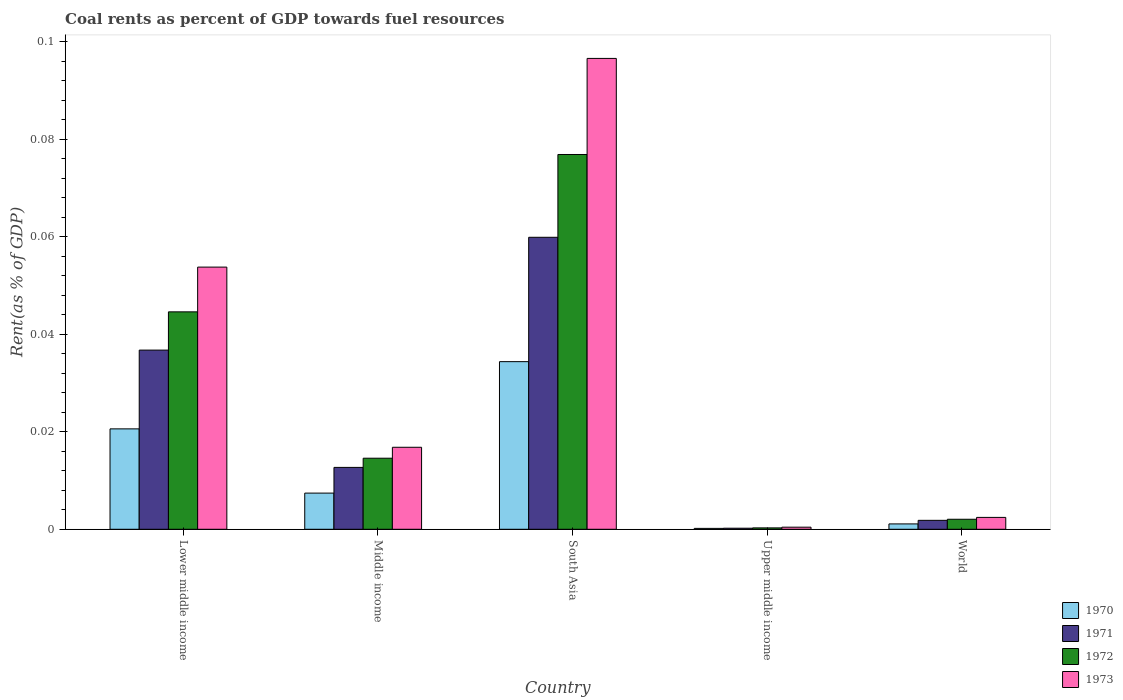How many different coloured bars are there?
Keep it short and to the point. 4. How many groups of bars are there?
Offer a terse response. 5. Are the number of bars on each tick of the X-axis equal?
Keep it short and to the point. Yes. How many bars are there on the 1st tick from the left?
Your answer should be very brief. 4. What is the label of the 5th group of bars from the left?
Give a very brief answer. World. What is the coal rent in 1972 in South Asia?
Your answer should be compact. 0.08. Across all countries, what is the maximum coal rent in 1973?
Your answer should be compact. 0.1. Across all countries, what is the minimum coal rent in 1970?
Offer a terse response. 0. In which country was the coal rent in 1972 maximum?
Make the answer very short. South Asia. In which country was the coal rent in 1973 minimum?
Make the answer very short. Upper middle income. What is the total coal rent in 1972 in the graph?
Provide a succinct answer. 0.14. What is the difference between the coal rent in 1972 in Lower middle income and that in South Asia?
Make the answer very short. -0.03. What is the difference between the coal rent in 1970 in Middle income and the coal rent in 1972 in South Asia?
Offer a terse response. -0.07. What is the average coal rent in 1973 per country?
Offer a terse response. 0.03. What is the difference between the coal rent of/in 1971 and coal rent of/in 1970 in Lower middle income?
Keep it short and to the point. 0.02. In how many countries, is the coal rent in 1970 greater than 0.056 %?
Offer a very short reply. 0. What is the ratio of the coal rent in 1971 in Middle income to that in World?
Your answer should be very brief. 6.93. Is the coal rent in 1973 in Lower middle income less than that in Middle income?
Offer a very short reply. No. What is the difference between the highest and the second highest coal rent in 1972?
Ensure brevity in your answer.  0.03. What is the difference between the highest and the lowest coal rent in 1971?
Provide a short and direct response. 0.06. Is it the case that in every country, the sum of the coal rent in 1970 and coal rent in 1972 is greater than the sum of coal rent in 1973 and coal rent in 1971?
Offer a terse response. No. What does the 1st bar from the left in Upper middle income represents?
Give a very brief answer. 1970. What does the 2nd bar from the right in South Asia represents?
Provide a succinct answer. 1972. What is the difference between two consecutive major ticks on the Y-axis?
Provide a short and direct response. 0.02. Are the values on the major ticks of Y-axis written in scientific E-notation?
Offer a very short reply. No. Where does the legend appear in the graph?
Give a very brief answer. Bottom right. How are the legend labels stacked?
Keep it short and to the point. Vertical. What is the title of the graph?
Keep it short and to the point. Coal rents as percent of GDP towards fuel resources. Does "1981" appear as one of the legend labels in the graph?
Offer a terse response. No. What is the label or title of the X-axis?
Offer a very short reply. Country. What is the label or title of the Y-axis?
Your response must be concise. Rent(as % of GDP). What is the Rent(as % of GDP) in 1970 in Lower middle income?
Your answer should be very brief. 0.02. What is the Rent(as % of GDP) of 1971 in Lower middle income?
Provide a short and direct response. 0.04. What is the Rent(as % of GDP) in 1972 in Lower middle income?
Give a very brief answer. 0.04. What is the Rent(as % of GDP) of 1973 in Lower middle income?
Your answer should be compact. 0.05. What is the Rent(as % of GDP) in 1970 in Middle income?
Your answer should be very brief. 0.01. What is the Rent(as % of GDP) of 1971 in Middle income?
Make the answer very short. 0.01. What is the Rent(as % of GDP) of 1972 in Middle income?
Your answer should be compact. 0.01. What is the Rent(as % of GDP) of 1973 in Middle income?
Keep it short and to the point. 0.02. What is the Rent(as % of GDP) in 1970 in South Asia?
Provide a short and direct response. 0.03. What is the Rent(as % of GDP) in 1971 in South Asia?
Ensure brevity in your answer.  0.06. What is the Rent(as % of GDP) in 1972 in South Asia?
Provide a succinct answer. 0.08. What is the Rent(as % of GDP) in 1973 in South Asia?
Your answer should be compact. 0.1. What is the Rent(as % of GDP) in 1970 in Upper middle income?
Your answer should be compact. 0. What is the Rent(as % of GDP) in 1971 in Upper middle income?
Give a very brief answer. 0. What is the Rent(as % of GDP) in 1972 in Upper middle income?
Your answer should be compact. 0. What is the Rent(as % of GDP) in 1973 in Upper middle income?
Keep it short and to the point. 0. What is the Rent(as % of GDP) of 1970 in World?
Your answer should be compact. 0. What is the Rent(as % of GDP) in 1971 in World?
Your response must be concise. 0. What is the Rent(as % of GDP) of 1972 in World?
Your response must be concise. 0. What is the Rent(as % of GDP) of 1973 in World?
Keep it short and to the point. 0. Across all countries, what is the maximum Rent(as % of GDP) of 1970?
Ensure brevity in your answer.  0.03. Across all countries, what is the maximum Rent(as % of GDP) of 1971?
Make the answer very short. 0.06. Across all countries, what is the maximum Rent(as % of GDP) in 1972?
Ensure brevity in your answer.  0.08. Across all countries, what is the maximum Rent(as % of GDP) of 1973?
Your answer should be very brief. 0.1. Across all countries, what is the minimum Rent(as % of GDP) of 1970?
Your response must be concise. 0. Across all countries, what is the minimum Rent(as % of GDP) of 1971?
Make the answer very short. 0. Across all countries, what is the minimum Rent(as % of GDP) of 1972?
Provide a succinct answer. 0. Across all countries, what is the minimum Rent(as % of GDP) of 1973?
Your answer should be compact. 0. What is the total Rent(as % of GDP) in 1970 in the graph?
Offer a terse response. 0.06. What is the total Rent(as % of GDP) of 1971 in the graph?
Ensure brevity in your answer.  0.11. What is the total Rent(as % of GDP) in 1972 in the graph?
Give a very brief answer. 0.14. What is the total Rent(as % of GDP) of 1973 in the graph?
Make the answer very short. 0.17. What is the difference between the Rent(as % of GDP) of 1970 in Lower middle income and that in Middle income?
Your response must be concise. 0.01. What is the difference between the Rent(as % of GDP) of 1971 in Lower middle income and that in Middle income?
Ensure brevity in your answer.  0.02. What is the difference between the Rent(as % of GDP) of 1972 in Lower middle income and that in Middle income?
Ensure brevity in your answer.  0.03. What is the difference between the Rent(as % of GDP) in 1973 in Lower middle income and that in Middle income?
Offer a very short reply. 0.04. What is the difference between the Rent(as % of GDP) in 1970 in Lower middle income and that in South Asia?
Keep it short and to the point. -0.01. What is the difference between the Rent(as % of GDP) in 1971 in Lower middle income and that in South Asia?
Your response must be concise. -0.02. What is the difference between the Rent(as % of GDP) of 1972 in Lower middle income and that in South Asia?
Your response must be concise. -0.03. What is the difference between the Rent(as % of GDP) in 1973 in Lower middle income and that in South Asia?
Offer a very short reply. -0.04. What is the difference between the Rent(as % of GDP) of 1970 in Lower middle income and that in Upper middle income?
Your answer should be very brief. 0.02. What is the difference between the Rent(as % of GDP) of 1971 in Lower middle income and that in Upper middle income?
Make the answer very short. 0.04. What is the difference between the Rent(as % of GDP) of 1972 in Lower middle income and that in Upper middle income?
Offer a very short reply. 0.04. What is the difference between the Rent(as % of GDP) in 1973 in Lower middle income and that in Upper middle income?
Offer a terse response. 0.05. What is the difference between the Rent(as % of GDP) in 1970 in Lower middle income and that in World?
Your answer should be very brief. 0.02. What is the difference between the Rent(as % of GDP) of 1971 in Lower middle income and that in World?
Offer a terse response. 0.03. What is the difference between the Rent(as % of GDP) in 1972 in Lower middle income and that in World?
Offer a very short reply. 0.04. What is the difference between the Rent(as % of GDP) of 1973 in Lower middle income and that in World?
Keep it short and to the point. 0.05. What is the difference between the Rent(as % of GDP) of 1970 in Middle income and that in South Asia?
Provide a succinct answer. -0.03. What is the difference between the Rent(as % of GDP) in 1971 in Middle income and that in South Asia?
Keep it short and to the point. -0.05. What is the difference between the Rent(as % of GDP) in 1972 in Middle income and that in South Asia?
Keep it short and to the point. -0.06. What is the difference between the Rent(as % of GDP) in 1973 in Middle income and that in South Asia?
Your response must be concise. -0.08. What is the difference between the Rent(as % of GDP) of 1970 in Middle income and that in Upper middle income?
Offer a very short reply. 0.01. What is the difference between the Rent(as % of GDP) in 1971 in Middle income and that in Upper middle income?
Make the answer very short. 0.01. What is the difference between the Rent(as % of GDP) of 1972 in Middle income and that in Upper middle income?
Give a very brief answer. 0.01. What is the difference between the Rent(as % of GDP) in 1973 in Middle income and that in Upper middle income?
Ensure brevity in your answer.  0.02. What is the difference between the Rent(as % of GDP) of 1970 in Middle income and that in World?
Provide a short and direct response. 0.01. What is the difference between the Rent(as % of GDP) in 1971 in Middle income and that in World?
Your answer should be compact. 0.01. What is the difference between the Rent(as % of GDP) in 1972 in Middle income and that in World?
Offer a very short reply. 0.01. What is the difference between the Rent(as % of GDP) in 1973 in Middle income and that in World?
Make the answer very short. 0.01. What is the difference between the Rent(as % of GDP) in 1970 in South Asia and that in Upper middle income?
Give a very brief answer. 0.03. What is the difference between the Rent(as % of GDP) of 1971 in South Asia and that in Upper middle income?
Offer a very short reply. 0.06. What is the difference between the Rent(as % of GDP) of 1972 in South Asia and that in Upper middle income?
Your answer should be compact. 0.08. What is the difference between the Rent(as % of GDP) of 1973 in South Asia and that in Upper middle income?
Your answer should be compact. 0.1. What is the difference between the Rent(as % of GDP) of 1971 in South Asia and that in World?
Provide a succinct answer. 0.06. What is the difference between the Rent(as % of GDP) in 1972 in South Asia and that in World?
Offer a very short reply. 0.07. What is the difference between the Rent(as % of GDP) in 1973 in South Asia and that in World?
Give a very brief answer. 0.09. What is the difference between the Rent(as % of GDP) in 1970 in Upper middle income and that in World?
Provide a succinct answer. -0. What is the difference between the Rent(as % of GDP) in 1971 in Upper middle income and that in World?
Provide a succinct answer. -0. What is the difference between the Rent(as % of GDP) of 1972 in Upper middle income and that in World?
Your response must be concise. -0. What is the difference between the Rent(as % of GDP) of 1973 in Upper middle income and that in World?
Give a very brief answer. -0. What is the difference between the Rent(as % of GDP) of 1970 in Lower middle income and the Rent(as % of GDP) of 1971 in Middle income?
Offer a very short reply. 0.01. What is the difference between the Rent(as % of GDP) of 1970 in Lower middle income and the Rent(as % of GDP) of 1972 in Middle income?
Your answer should be compact. 0.01. What is the difference between the Rent(as % of GDP) in 1970 in Lower middle income and the Rent(as % of GDP) in 1973 in Middle income?
Keep it short and to the point. 0. What is the difference between the Rent(as % of GDP) in 1971 in Lower middle income and the Rent(as % of GDP) in 1972 in Middle income?
Your answer should be compact. 0.02. What is the difference between the Rent(as % of GDP) of 1971 in Lower middle income and the Rent(as % of GDP) of 1973 in Middle income?
Offer a very short reply. 0.02. What is the difference between the Rent(as % of GDP) of 1972 in Lower middle income and the Rent(as % of GDP) of 1973 in Middle income?
Make the answer very short. 0.03. What is the difference between the Rent(as % of GDP) of 1970 in Lower middle income and the Rent(as % of GDP) of 1971 in South Asia?
Ensure brevity in your answer.  -0.04. What is the difference between the Rent(as % of GDP) in 1970 in Lower middle income and the Rent(as % of GDP) in 1972 in South Asia?
Provide a succinct answer. -0.06. What is the difference between the Rent(as % of GDP) of 1970 in Lower middle income and the Rent(as % of GDP) of 1973 in South Asia?
Your response must be concise. -0.08. What is the difference between the Rent(as % of GDP) of 1971 in Lower middle income and the Rent(as % of GDP) of 1972 in South Asia?
Offer a very short reply. -0.04. What is the difference between the Rent(as % of GDP) of 1971 in Lower middle income and the Rent(as % of GDP) of 1973 in South Asia?
Keep it short and to the point. -0.06. What is the difference between the Rent(as % of GDP) of 1972 in Lower middle income and the Rent(as % of GDP) of 1973 in South Asia?
Provide a short and direct response. -0.05. What is the difference between the Rent(as % of GDP) in 1970 in Lower middle income and the Rent(as % of GDP) in 1971 in Upper middle income?
Your response must be concise. 0.02. What is the difference between the Rent(as % of GDP) of 1970 in Lower middle income and the Rent(as % of GDP) of 1972 in Upper middle income?
Ensure brevity in your answer.  0.02. What is the difference between the Rent(as % of GDP) in 1970 in Lower middle income and the Rent(as % of GDP) in 1973 in Upper middle income?
Ensure brevity in your answer.  0.02. What is the difference between the Rent(as % of GDP) of 1971 in Lower middle income and the Rent(as % of GDP) of 1972 in Upper middle income?
Your answer should be very brief. 0.04. What is the difference between the Rent(as % of GDP) of 1971 in Lower middle income and the Rent(as % of GDP) of 1973 in Upper middle income?
Provide a short and direct response. 0.04. What is the difference between the Rent(as % of GDP) in 1972 in Lower middle income and the Rent(as % of GDP) in 1973 in Upper middle income?
Your response must be concise. 0.04. What is the difference between the Rent(as % of GDP) of 1970 in Lower middle income and the Rent(as % of GDP) of 1971 in World?
Your response must be concise. 0.02. What is the difference between the Rent(as % of GDP) in 1970 in Lower middle income and the Rent(as % of GDP) in 1972 in World?
Provide a short and direct response. 0.02. What is the difference between the Rent(as % of GDP) in 1970 in Lower middle income and the Rent(as % of GDP) in 1973 in World?
Your answer should be compact. 0.02. What is the difference between the Rent(as % of GDP) in 1971 in Lower middle income and the Rent(as % of GDP) in 1972 in World?
Provide a succinct answer. 0.03. What is the difference between the Rent(as % of GDP) in 1971 in Lower middle income and the Rent(as % of GDP) in 1973 in World?
Offer a terse response. 0.03. What is the difference between the Rent(as % of GDP) of 1972 in Lower middle income and the Rent(as % of GDP) of 1973 in World?
Your answer should be compact. 0.04. What is the difference between the Rent(as % of GDP) in 1970 in Middle income and the Rent(as % of GDP) in 1971 in South Asia?
Your answer should be compact. -0.05. What is the difference between the Rent(as % of GDP) of 1970 in Middle income and the Rent(as % of GDP) of 1972 in South Asia?
Your response must be concise. -0.07. What is the difference between the Rent(as % of GDP) of 1970 in Middle income and the Rent(as % of GDP) of 1973 in South Asia?
Give a very brief answer. -0.09. What is the difference between the Rent(as % of GDP) in 1971 in Middle income and the Rent(as % of GDP) in 1972 in South Asia?
Your response must be concise. -0.06. What is the difference between the Rent(as % of GDP) in 1971 in Middle income and the Rent(as % of GDP) in 1973 in South Asia?
Your answer should be compact. -0.08. What is the difference between the Rent(as % of GDP) of 1972 in Middle income and the Rent(as % of GDP) of 1973 in South Asia?
Ensure brevity in your answer.  -0.08. What is the difference between the Rent(as % of GDP) in 1970 in Middle income and the Rent(as % of GDP) in 1971 in Upper middle income?
Your answer should be very brief. 0.01. What is the difference between the Rent(as % of GDP) of 1970 in Middle income and the Rent(as % of GDP) of 1972 in Upper middle income?
Ensure brevity in your answer.  0.01. What is the difference between the Rent(as % of GDP) in 1970 in Middle income and the Rent(as % of GDP) in 1973 in Upper middle income?
Offer a very short reply. 0.01. What is the difference between the Rent(as % of GDP) in 1971 in Middle income and the Rent(as % of GDP) in 1972 in Upper middle income?
Your response must be concise. 0.01. What is the difference between the Rent(as % of GDP) in 1971 in Middle income and the Rent(as % of GDP) in 1973 in Upper middle income?
Provide a succinct answer. 0.01. What is the difference between the Rent(as % of GDP) in 1972 in Middle income and the Rent(as % of GDP) in 1973 in Upper middle income?
Your answer should be compact. 0.01. What is the difference between the Rent(as % of GDP) in 1970 in Middle income and the Rent(as % of GDP) in 1971 in World?
Provide a short and direct response. 0.01. What is the difference between the Rent(as % of GDP) of 1970 in Middle income and the Rent(as % of GDP) of 1972 in World?
Your answer should be compact. 0.01. What is the difference between the Rent(as % of GDP) in 1970 in Middle income and the Rent(as % of GDP) in 1973 in World?
Your response must be concise. 0.01. What is the difference between the Rent(as % of GDP) of 1971 in Middle income and the Rent(as % of GDP) of 1972 in World?
Give a very brief answer. 0.01. What is the difference between the Rent(as % of GDP) in 1971 in Middle income and the Rent(as % of GDP) in 1973 in World?
Your answer should be compact. 0.01. What is the difference between the Rent(as % of GDP) in 1972 in Middle income and the Rent(as % of GDP) in 1973 in World?
Give a very brief answer. 0.01. What is the difference between the Rent(as % of GDP) in 1970 in South Asia and the Rent(as % of GDP) in 1971 in Upper middle income?
Give a very brief answer. 0.03. What is the difference between the Rent(as % of GDP) of 1970 in South Asia and the Rent(as % of GDP) of 1972 in Upper middle income?
Your answer should be compact. 0.03. What is the difference between the Rent(as % of GDP) of 1970 in South Asia and the Rent(as % of GDP) of 1973 in Upper middle income?
Give a very brief answer. 0.03. What is the difference between the Rent(as % of GDP) in 1971 in South Asia and the Rent(as % of GDP) in 1972 in Upper middle income?
Make the answer very short. 0.06. What is the difference between the Rent(as % of GDP) of 1971 in South Asia and the Rent(as % of GDP) of 1973 in Upper middle income?
Provide a short and direct response. 0.06. What is the difference between the Rent(as % of GDP) in 1972 in South Asia and the Rent(as % of GDP) in 1973 in Upper middle income?
Your answer should be very brief. 0.08. What is the difference between the Rent(as % of GDP) in 1970 in South Asia and the Rent(as % of GDP) in 1971 in World?
Your response must be concise. 0.03. What is the difference between the Rent(as % of GDP) of 1970 in South Asia and the Rent(as % of GDP) of 1972 in World?
Offer a very short reply. 0.03. What is the difference between the Rent(as % of GDP) of 1970 in South Asia and the Rent(as % of GDP) of 1973 in World?
Ensure brevity in your answer.  0.03. What is the difference between the Rent(as % of GDP) of 1971 in South Asia and the Rent(as % of GDP) of 1972 in World?
Provide a short and direct response. 0.06. What is the difference between the Rent(as % of GDP) of 1971 in South Asia and the Rent(as % of GDP) of 1973 in World?
Provide a succinct answer. 0.06. What is the difference between the Rent(as % of GDP) in 1972 in South Asia and the Rent(as % of GDP) in 1973 in World?
Offer a terse response. 0.07. What is the difference between the Rent(as % of GDP) of 1970 in Upper middle income and the Rent(as % of GDP) of 1971 in World?
Offer a very short reply. -0. What is the difference between the Rent(as % of GDP) in 1970 in Upper middle income and the Rent(as % of GDP) in 1972 in World?
Your answer should be compact. -0. What is the difference between the Rent(as % of GDP) in 1970 in Upper middle income and the Rent(as % of GDP) in 1973 in World?
Make the answer very short. -0. What is the difference between the Rent(as % of GDP) in 1971 in Upper middle income and the Rent(as % of GDP) in 1972 in World?
Keep it short and to the point. -0. What is the difference between the Rent(as % of GDP) of 1971 in Upper middle income and the Rent(as % of GDP) of 1973 in World?
Ensure brevity in your answer.  -0. What is the difference between the Rent(as % of GDP) in 1972 in Upper middle income and the Rent(as % of GDP) in 1973 in World?
Your answer should be very brief. -0. What is the average Rent(as % of GDP) in 1970 per country?
Provide a succinct answer. 0.01. What is the average Rent(as % of GDP) of 1971 per country?
Give a very brief answer. 0.02. What is the average Rent(as % of GDP) in 1972 per country?
Keep it short and to the point. 0.03. What is the average Rent(as % of GDP) in 1973 per country?
Provide a short and direct response. 0.03. What is the difference between the Rent(as % of GDP) in 1970 and Rent(as % of GDP) in 1971 in Lower middle income?
Make the answer very short. -0.02. What is the difference between the Rent(as % of GDP) in 1970 and Rent(as % of GDP) in 1972 in Lower middle income?
Give a very brief answer. -0.02. What is the difference between the Rent(as % of GDP) in 1970 and Rent(as % of GDP) in 1973 in Lower middle income?
Give a very brief answer. -0.03. What is the difference between the Rent(as % of GDP) of 1971 and Rent(as % of GDP) of 1972 in Lower middle income?
Keep it short and to the point. -0.01. What is the difference between the Rent(as % of GDP) of 1971 and Rent(as % of GDP) of 1973 in Lower middle income?
Offer a terse response. -0.02. What is the difference between the Rent(as % of GDP) in 1972 and Rent(as % of GDP) in 1973 in Lower middle income?
Provide a short and direct response. -0.01. What is the difference between the Rent(as % of GDP) of 1970 and Rent(as % of GDP) of 1971 in Middle income?
Give a very brief answer. -0.01. What is the difference between the Rent(as % of GDP) of 1970 and Rent(as % of GDP) of 1972 in Middle income?
Keep it short and to the point. -0.01. What is the difference between the Rent(as % of GDP) in 1970 and Rent(as % of GDP) in 1973 in Middle income?
Your response must be concise. -0.01. What is the difference between the Rent(as % of GDP) in 1971 and Rent(as % of GDP) in 1972 in Middle income?
Offer a very short reply. -0. What is the difference between the Rent(as % of GDP) of 1971 and Rent(as % of GDP) of 1973 in Middle income?
Provide a succinct answer. -0. What is the difference between the Rent(as % of GDP) of 1972 and Rent(as % of GDP) of 1973 in Middle income?
Offer a terse response. -0. What is the difference between the Rent(as % of GDP) of 1970 and Rent(as % of GDP) of 1971 in South Asia?
Your answer should be very brief. -0.03. What is the difference between the Rent(as % of GDP) of 1970 and Rent(as % of GDP) of 1972 in South Asia?
Make the answer very short. -0.04. What is the difference between the Rent(as % of GDP) in 1970 and Rent(as % of GDP) in 1973 in South Asia?
Provide a succinct answer. -0.06. What is the difference between the Rent(as % of GDP) in 1971 and Rent(as % of GDP) in 1972 in South Asia?
Make the answer very short. -0.02. What is the difference between the Rent(as % of GDP) of 1971 and Rent(as % of GDP) of 1973 in South Asia?
Ensure brevity in your answer.  -0.04. What is the difference between the Rent(as % of GDP) in 1972 and Rent(as % of GDP) in 1973 in South Asia?
Provide a short and direct response. -0.02. What is the difference between the Rent(as % of GDP) in 1970 and Rent(as % of GDP) in 1972 in Upper middle income?
Offer a terse response. -0. What is the difference between the Rent(as % of GDP) of 1970 and Rent(as % of GDP) of 1973 in Upper middle income?
Offer a terse response. -0. What is the difference between the Rent(as % of GDP) in 1971 and Rent(as % of GDP) in 1972 in Upper middle income?
Your answer should be compact. -0. What is the difference between the Rent(as % of GDP) of 1971 and Rent(as % of GDP) of 1973 in Upper middle income?
Your response must be concise. -0. What is the difference between the Rent(as % of GDP) of 1972 and Rent(as % of GDP) of 1973 in Upper middle income?
Provide a succinct answer. -0. What is the difference between the Rent(as % of GDP) of 1970 and Rent(as % of GDP) of 1971 in World?
Your response must be concise. -0. What is the difference between the Rent(as % of GDP) in 1970 and Rent(as % of GDP) in 1972 in World?
Give a very brief answer. -0. What is the difference between the Rent(as % of GDP) of 1970 and Rent(as % of GDP) of 1973 in World?
Your answer should be very brief. -0. What is the difference between the Rent(as % of GDP) of 1971 and Rent(as % of GDP) of 1972 in World?
Your answer should be compact. -0. What is the difference between the Rent(as % of GDP) in 1971 and Rent(as % of GDP) in 1973 in World?
Provide a short and direct response. -0. What is the difference between the Rent(as % of GDP) of 1972 and Rent(as % of GDP) of 1973 in World?
Give a very brief answer. -0. What is the ratio of the Rent(as % of GDP) in 1970 in Lower middle income to that in Middle income?
Offer a terse response. 2.78. What is the ratio of the Rent(as % of GDP) in 1971 in Lower middle income to that in Middle income?
Your response must be concise. 2.9. What is the ratio of the Rent(as % of GDP) of 1972 in Lower middle income to that in Middle income?
Provide a short and direct response. 3.06. What is the ratio of the Rent(as % of GDP) of 1973 in Lower middle income to that in Middle income?
Your response must be concise. 3.2. What is the ratio of the Rent(as % of GDP) in 1970 in Lower middle income to that in South Asia?
Provide a succinct answer. 0.6. What is the ratio of the Rent(as % of GDP) in 1971 in Lower middle income to that in South Asia?
Your response must be concise. 0.61. What is the ratio of the Rent(as % of GDP) of 1972 in Lower middle income to that in South Asia?
Make the answer very short. 0.58. What is the ratio of the Rent(as % of GDP) of 1973 in Lower middle income to that in South Asia?
Ensure brevity in your answer.  0.56. What is the ratio of the Rent(as % of GDP) of 1970 in Lower middle income to that in Upper middle income?
Give a very brief answer. 112.03. What is the ratio of the Rent(as % of GDP) of 1971 in Lower middle income to that in Upper middle income?
Offer a very short reply. 167.98. What is the ratio of the Rent(as % of GDP) of 1972 in Lower middle income to that in Upper middle income?
Keep it short and to the point. 156.82. What is the ratio of the Rent(as % of GDP) of 1973 in Lower middle income to that in Upper middle income?
Your response must be concise. 124.82. What is the ratio of the Rent(as % of GDP) in 1970 in Lower middle income to that in World?
Give a very brief answer. 18.71. What is the ratio of the Rent(as % of GDP) in 1971 in Lower middle income to that in World?
Your response must be concise. 20.06. What is the ratio of the Rent(as % of GDP) in 1972 in Lower middle income to that in World?
Your answer should be very brief. 21.7. What is the ratio of the Rent(as % of GDP) in 1973 in Lower middle income to that in World?
Offer a very short reply. 22.07. What is the ratio of the Rent(as % of GDP) in 1970 in Middle income to that in South Asia?
Give a very brief answer. 0.22. What is the ratio of the Rent(as % of GDP) in 1971 in Middle income to that in South Asia?
Your answer should be very brief. 0.21. What is the ratio of the Rent(as % of GDP) of 1972 in Middle income to that in South Asia?
Ensure brevity in your answer.  0.19. What is the ratio of the Rent(as % of GDP) of 1973 in Middle income to that in South Asia?
Keep it short and to the point. 0.17. What is the ratio of the Rent(as % of GDP) of 1970 in Middle income to that in Upper middle income?
Make the answer very short. 40.36. What is the ratio of the Rent(as % of GDP) of 1971 in Middle income to that in Upper middle income?
Offer a very short reply. 58.01. What is the ratio of the Rent(as % of GDP) of 1972 in Middle income to that in Upper middle income?
Provide a short and direct response. 51.25. What is the ratio of the Rent(as % of GDP) of 1973 in Middle income to that in Upper middle income?
Provide a short and direct response. 39.04. What is the ratio of the Rent(as % of GDP) of 1970 in Middle income to that in World?
Your answer should be very brief. 6.74. What is the ratio of the Rent(as % of GDP) of 1971 in Middle income to that in World?
Your response must be concise. 6.93. What is the ratio of the Rent(as % of GDP) in 1972 in Middle income to that in World?
Make the answer very short. 7.09. What is the ratio of the Rent(as % of GDP) in 1973 in Middle income to that in World?
Your answer should be very brief. 6.91. What is the ratio of the Rent(as % of GDP) of 1970 in South Asia to that in Upper middle income?
Your answer should be very brief. 187.05. What is the ratio of the Rent(as % of GDP) in 1971 in South Asia to that in Upper middle income?
Give a very brief answer. 273.74. What is the ratio of the Rent(as % of GDP) in 1972 in South Asia to that in Upper middle income?
Ensure brevity in your answer.  270.32. What is the ratio of the Rent(as % of GDP) in 1973 in South Asia to that in Upper middle income?
Keep it short and to the point. 224.18. What is the ratio of the Rent(as % of GDP) in 1970 in South Asia to that in World?
Keep it short and to the point. 31.24. What is the ratio of the Rent(as % of GDP) in 1971 in South Asia to that in World?
Provide a succinct answer. 32.69. What is the ratio of the Rent(as % of GDP) of 1972 in South Asia to that in World?
Your answer should be very brief. 37.41. What is the ratio of the Rent(as % of GDP) of 1973 in South Asia to that in World?
Your response must be concise. 39.65. What is the ratio of the Rent(as % of GDP) in 1970 in Upper middle income to that in World?
Keep it short and to the point. 0.17. What is the ratio of the Rent(as % of GDP) in 1971 in Upper middle income to that in World?
Keep it short and to the point. 0.12. What is the ratio of the Rent(as % of GDP) in 1972 in Upper middle income to that in World?
Your response must be concise. 0.14. What is the ratio of the Rent(as % of GDP) of 1973 in Upper middle income to that in World?
Make the answer very short. 0.18. What is the difference between the highest and the second highest Rent(as % of GDP) in 1970?
Your answer should be very brief. 0.01. What is the difference between the highest and the second highest Rent(as % of GDP) of 1971?
Give a very brief answer. 0.02. What is the difference between the highest and the second highest Rent(as % of GDP) in 1972?
Keep it short and to the point. 0.03. What is the difference between the highest and the second highest Rent(as % of GDP) of 1973?
Your response must be concise. 0.04. What is the difference between the highest and the lowest Rent(as % of GDP) of 1970?
Your answer should be very brief. 0.03. What is the difference between the highest and the lowest Rent(as % of GDP) in 1971?
Keep it short and to the point. 0.06. What is the difference between the highest and the lowest Rent(as % of GDP) in 1972?
Your answer should be compact. 0.08. What is the difference between the highest and the lowest Rent(as % of GDP) of 1973?
Ensure brevity in your answer.  0.1. 